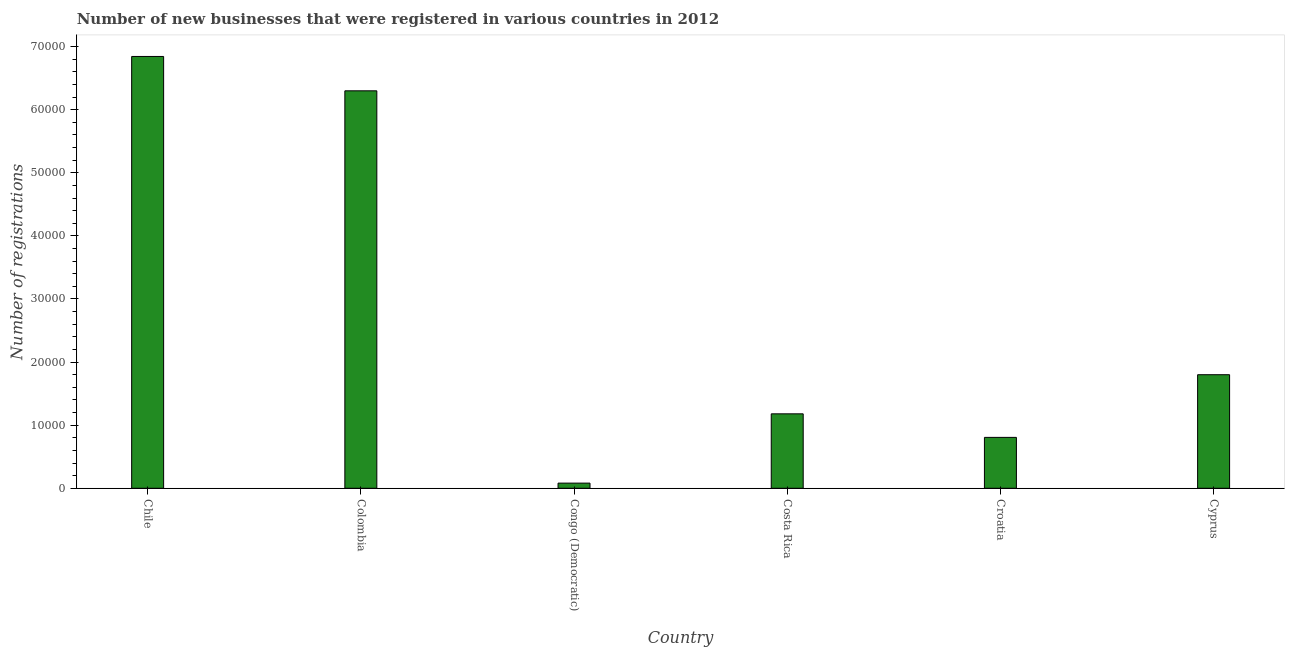Does the graph contain any zero values?
Provide a short and direct response. No. What is the title of the graph?
Your answer should be compact. Number of new businesses that were registered in various countries in 2012. What is the label or title of the X-axis?
Your response must be concise. Country. What is the label or title of the Y-axis?
Provide a succinct answer. Number of registrations. What is the number of new business registrations in Colombia?
Keep it short and to the point. 6.30e+04. Across all countries, what is the maximum number of new business registrations?
Provide a short and direct response. 6.84e+04. Across all countries, what is the minimum number of new business registrations?
Provide a succinct answer. 819. In which country was the number of new business registrations maximum?
Give a very brief answer. Chile. In which country was the number of new business registrations minimum?
Offer a very short reply. Congo (Democratic). What is the sum of the number of new business registrations?
Give a very brief answer. 1.70e+05. What is the difference between the number of new business registrations in Congo (Democratic) and Croatia?
Your answer should be compact. -7249. What is the average number of new business registrations per country?
Provide a short and direct response. 2.84e+04. What is the median number of new business registrations?
Give a very brief answer. 1.49e+04. In how many countries, is the number of new business registrations greater than 2000 ?
Make the answer very short. 5. Is the difference between the number of new business registrations in Chile and Congo (Democratic) greater than the difference between any two countries?
Your answer should be very brief. Yes. What is the difference between the highest and the second highest number of new business registrations?
Your response must be concise. 5446. What is the difference between the highest and the lowest number of new business registrations?
Make the answer very short. 6.76e+04. In how many countries, is the number of new business registrations greater than the average number of new business registrations taken over all countries?
Your answer should be very brief. 2. Are all the bars in the graph horizontal?
Make the answer very short. No. What is the difference between two consecutive major ticks on the Y-axis?
Offer a terse response. 10000. Are the values on the major ticks of Y-axis written in scientific E-notation?
Your answer should be very brief. No. What is the Number of registrations of Chile?
Your answer should be very brief. 6.84e+04. What is the Number of registrations in Colombia?
Provide a succinct answer. 6.30e+04. What is the Number of registrations in Congo (Democratic)?
Give a very brief answer. 819. What is the Number of registrations of Costa Rica?
Make the answer very short. 1.18e+04. What is the Number of registrations in Croatia?
Your answer should be very brief. 8068. What is the Number of registrations in Cyprus?
Offer a very short reply. 1.80e+04. What is the difference between the Number of registrations in Chile and Colombia?
Ensure brevity in your answer.  5446. What is the difference between the Number of registrations in Chile and Congo (Democratic)?
Give a very brief answer. 6.76e+04. What is the difference between the Number of registrations in Chile and Costa Rica?
Provide a succinct answer. 5.66e+04. What is the difference between the Number of registrations in Chile and Croatia?
Your answer should be very brief. 6.04e+04. What is the difference between the Number of registrations in Chile and Cyprus?
Offer a very short reply. 5.04e+04. What is the difference between the Number of registrations in Colombia and Congo (Democratic)?
Keep it short and to the point. 6.22e+04. What is the difference between the Number of registrations in Colombia and Costa Rica?
Offer a very short reply. 5.12e+04. What is the difference between the Number of registrations in Colombia and Croatia?
Give a very brief answer. 5.49e+04. What is the difference between the Number of registrations in Colombia and Cyprus?
Offer a very short reply. 4.50e+04. What is the difference between the Number of registrations in Congo (Democratic) and Costa Rica?
Offer a very short reply. -1.10e+04. What is the difference between the Number of registrations in Congo (Democratic) and Croatia?
Give a very brief answer. -7249. What is the difference between the Number of registrations in Congo (Democratic) and Cyprus?
Ensure brevity in your answer.  -1.72e+04. What is the difference between the Number of registrations in Costa Rica and Croatia?
Offer a very short reply. 3732. What is the difference between the Number of registrations in Costa Rica and Cyprus?
Ensure brevity in your answer.  -6199. What is the difference between the Number of registrations in Croatia and Cyprus?
Give a very brief answer. -9931. What is the ratio of the Number of registrations in Chile to that in Colombia?
Your response must be concise. 1.09. What is the ratio of the Number of registrations in Chile to that in Congo (Democratic)?
Your response must be concise. 83.56. What is the ratio of the Number of registrations in Chile to that in Croatia?
Ensure brevity in your answer.  8.48. What is the ratio of the Number of registrations in Chile to that in Cyprus?
Offer a very short reply. 3.8. What is the ratio of the Number of registrations in Colombia to that in Congo (Democratic)?
Give a very brief answer. 76.92. What is the ratio of the Number of registrations in Colombia to that in Costa Rica?
Offer a terse response. 5.34. What is the ratio of the Number of registrations in Colombia to that in Croatia?
Keep it short and to the point. 7.81. What is the ratio of the Number of registrations in Colombia to that in Cyprus?
Your answer should be compact. 3.5. What is the ratio of the Number of registrations in Congo (Democratic) to that in Costa Rica?
Provide a short and direct response. 0.07. What is the ratio of the Number of registrations in Congo (Democratic) to that in Croatia?
Make the answer very short. 0.1. What is the ratio of the Number of registrations in Congo (Democratic) to that in Cyprus?
Your answer should be very brief. 0.05. What is the ratio of the Number of registrations in Costa Rica to that in Croatia?
Keep it short and to the point. 1.46. What is the ratio of the Number of registrations in Costa Rica to that in Cyprus?
Provide a succinct answer. 0.66. What is the ratio of the Number of registrations in Croatia to that in Cyprus?
Your answer should be very brief. 0.45. 